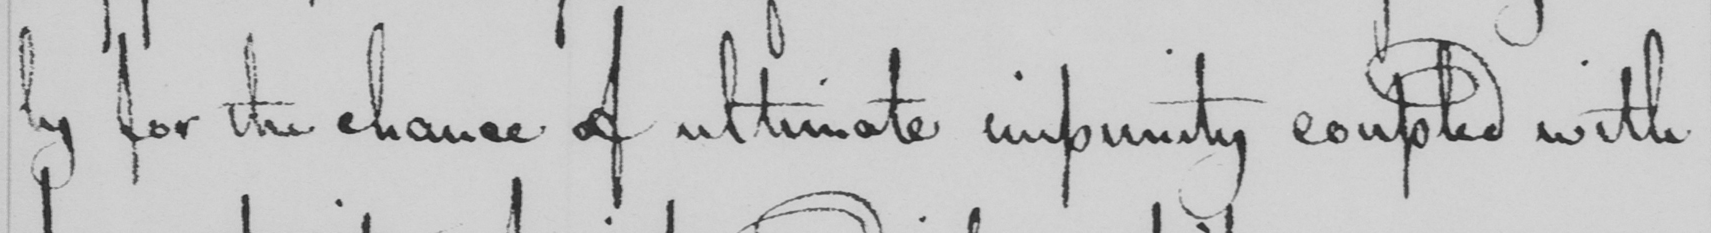What does this handwritten line say? ly for the chance of ultimate impunity coupled with 